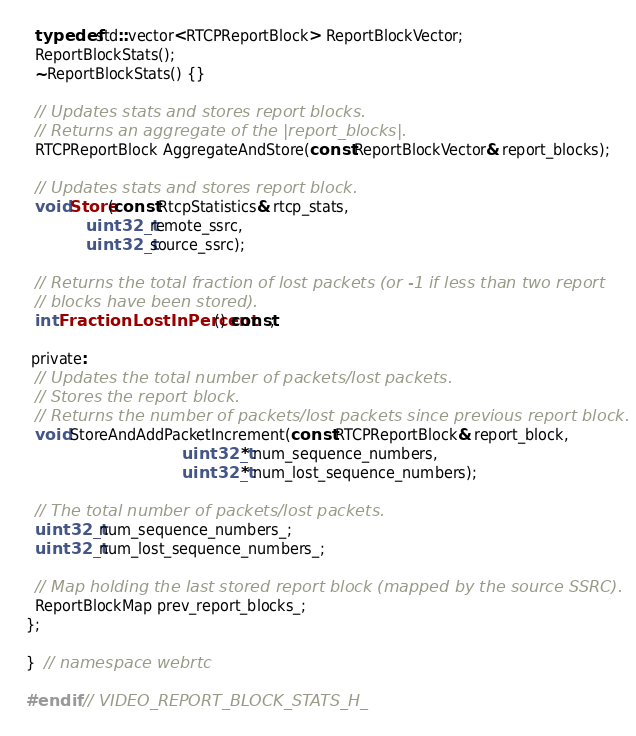Convert code to text. <code><loc_0><loc_0><loc_500><loc_500><_C_>  typedef std::vector<RTCPReportBlock> ReportBlockVector;
  ReportBlockStats();
  ~ReportBlockStats() {}

  // Updates stats and stores report blocks.
  // Returns an aggregate of the |report_blocks|.
  RTCPReportBlock AggregateAndStore(const ReportBlockVector& report_blocks);

  // Updates stats and stores report block.
  void Store(const RtcpStatistics& rtcp_stats,
             uint32_t remote_ssrc,
             uint32_t source_ssrc);

  // Returns the total fraction of lost packets (or -1 if less than two report
  // blocks have been stored).
  int FractionLostInPercent() const;

 private:
  // Updates the total number of packets/lost packets.
  // Stores the report block.
  // Returns the number of packets/lost packets since previous report block.
  void StoreAndAddPacketIncrement(const RTCPReportBlock& report_block,
                                  uint32_t* num_sequence_numbers,
                                  uint32_t* num_lost_sequence_numbers);

  // The total number of packets/lost packets.
  uint32_t num_sequence_numbers_;
  uint32_t num_lost_sequence_numbers_;

  // Map holding the last stored report block (mapped by the source SSRC).
  ReportBlockMap prev_report_blocks_;
};

}  // namespace webrtc

#endif  // VIDEO_REPORT_BLOCK_STATS_H_

</code> 